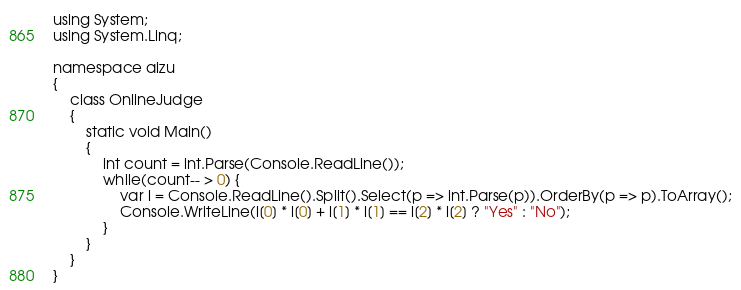Convert code to text. <code><loc_0><loc_0><loc_500><loc_500><_C#_>using System;
using System.Linq;

namespace aizu
{
    class OnlineJudge
    {
        static void Main()
        {
            int count = int.Parse(Console.ReadLine());
            while(count-- > 0) {
                var l = Console.ReadLine().Split().Select(p => int.Parse(p)).OrderBy(p => p).ToArray();
                Console.WriteLine(l[0] * l[0] + l[1] * l[1] == l[2] * l[2] ? "Yes" : "No");
            }
        }
    }
}</code> 